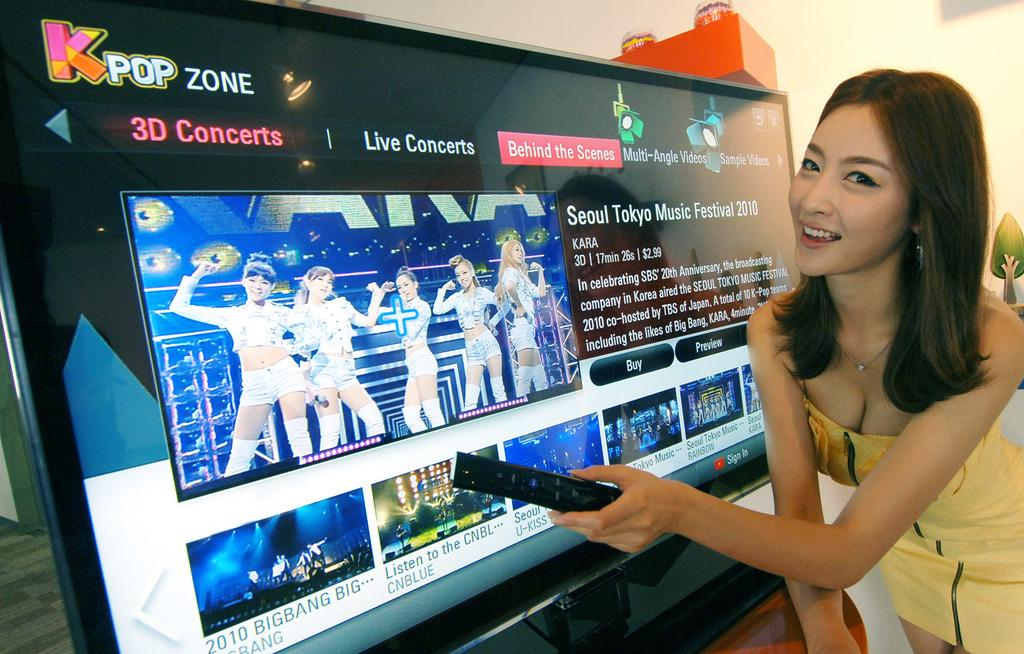<image>
Create a compact narrative representing the image presented. A woman stands next to a tv which is playing 3D concerts on KPop Zone. 